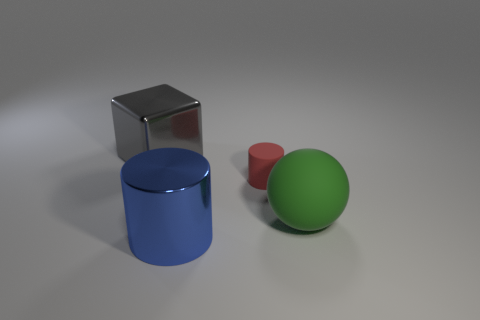How many blue cylinders are the same size as the blue shiny object? In the image provided, there is only one blue cylinder, and it happens to be the same size as the shiny object, which is also blue. Therefore, the count of blue cylinders that match the size of the shiny blue object is one. 